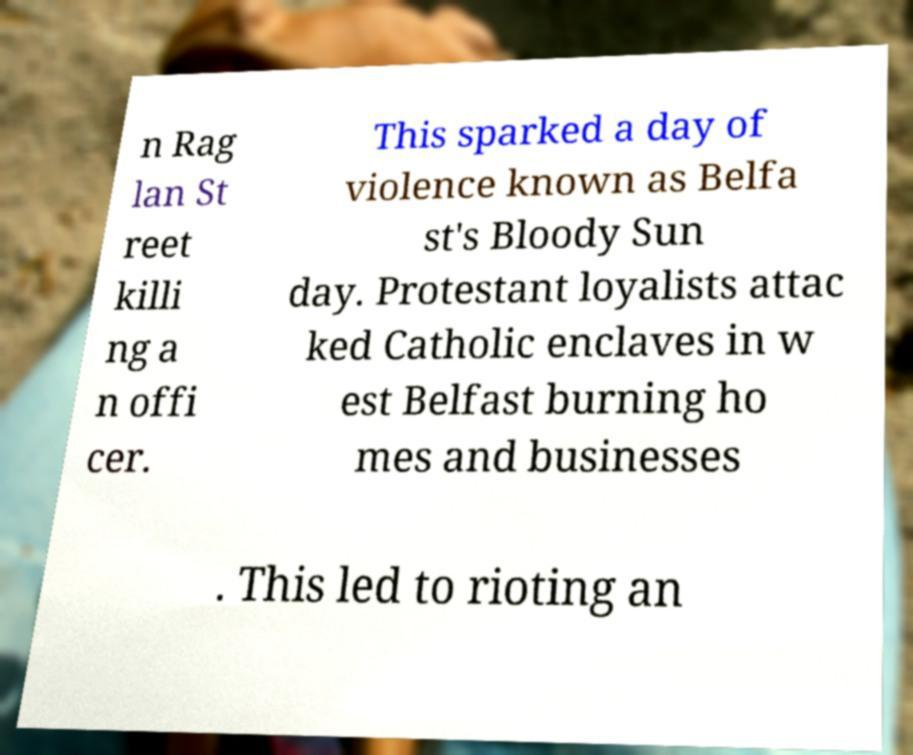Can you accurately transcribe the text from the provided image for me? n Rag lan St reet killi ng a n offi cer. This sparked a day of violence known as Belfa st's Bloody Sun day. Protestant loyalists attac ked Catholic enclaves in w est Belfast burning ho mes and businesses . This led to rioting an 